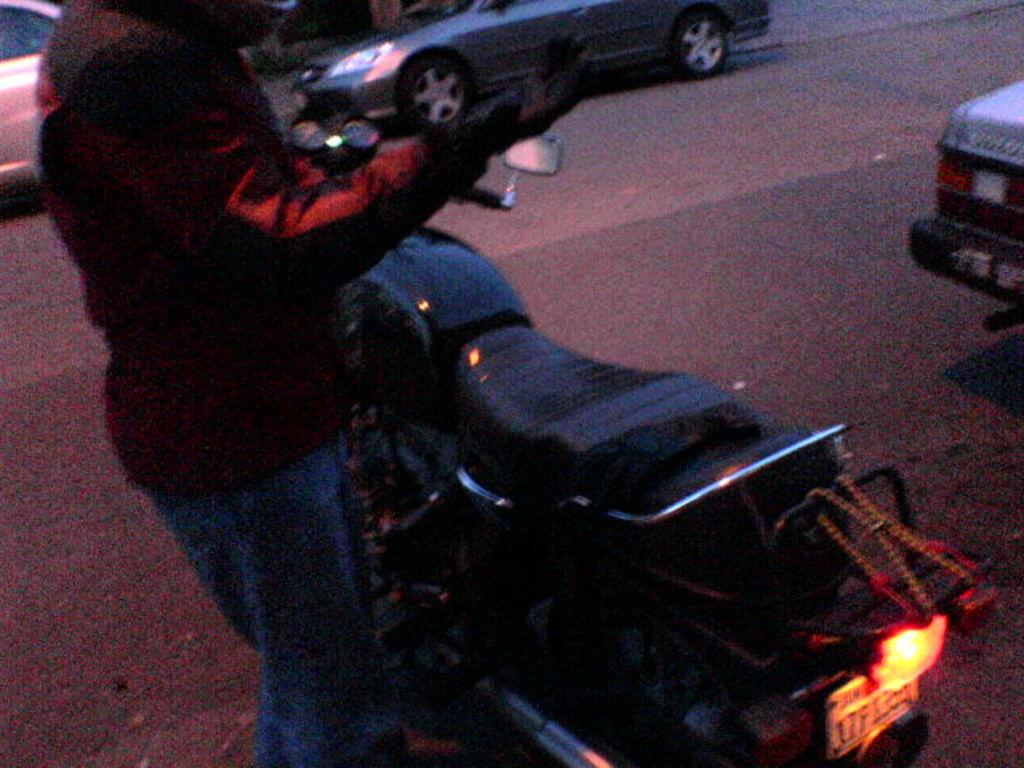What type of vehicles are present in the image? There are cars in the image. What other mode of transportation can be seen in the image? There is a bike in the image. Can you describe the person in the image? There is a person on the road in the image. How many tomatoes are hanging from the bike in the image? There are no tomatoes present in the image, and they are not hanging from the bike. 